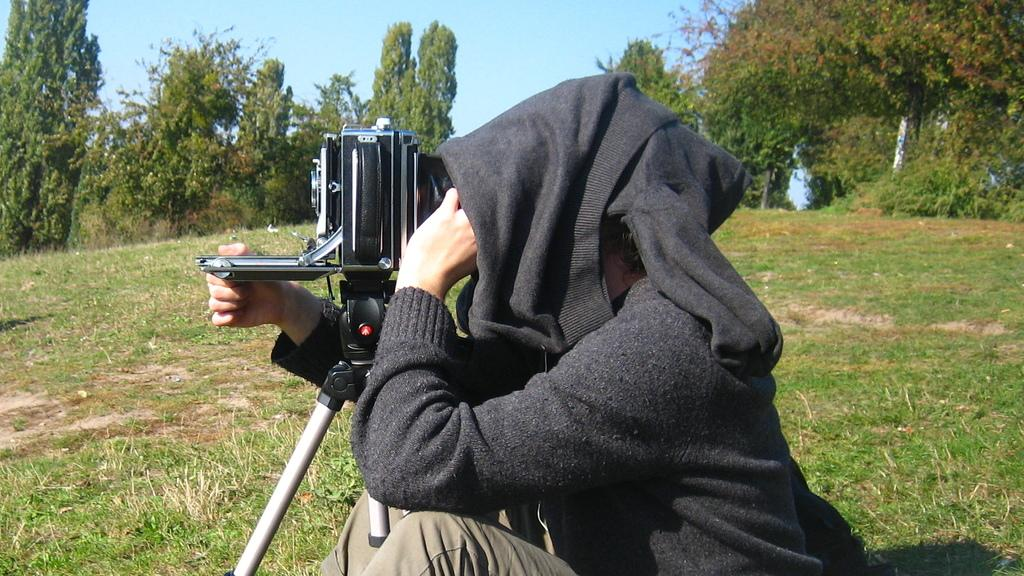What is the person in the image doing? The person is sitting on the ground and using a camera attached to a stand. What can be seen in the background of the image? There are trees and the sky visible in the background. Can you describe the person's position in relation to the camera? The person is sitting on the ground and using the camera, which is attached to a stand. What type of shade is being used to protect the camera from the weather in the image? There is no shade present in the image, and the weather is not mentioned. The camera is attached to a stand and being used by the person sitting on the ground. 